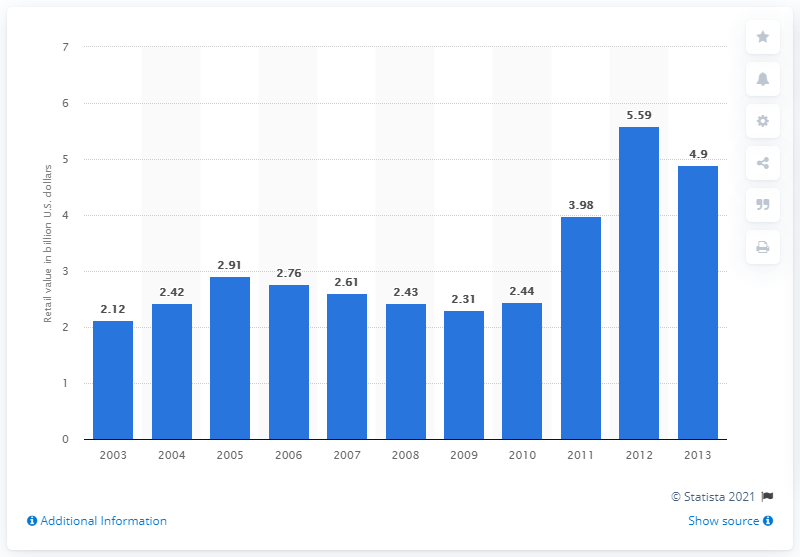Indicate a few pertinent items in this graphic. In 2010, the recreational boating accessory aftermarket was valued at approximately 2.44 billion dollars. 